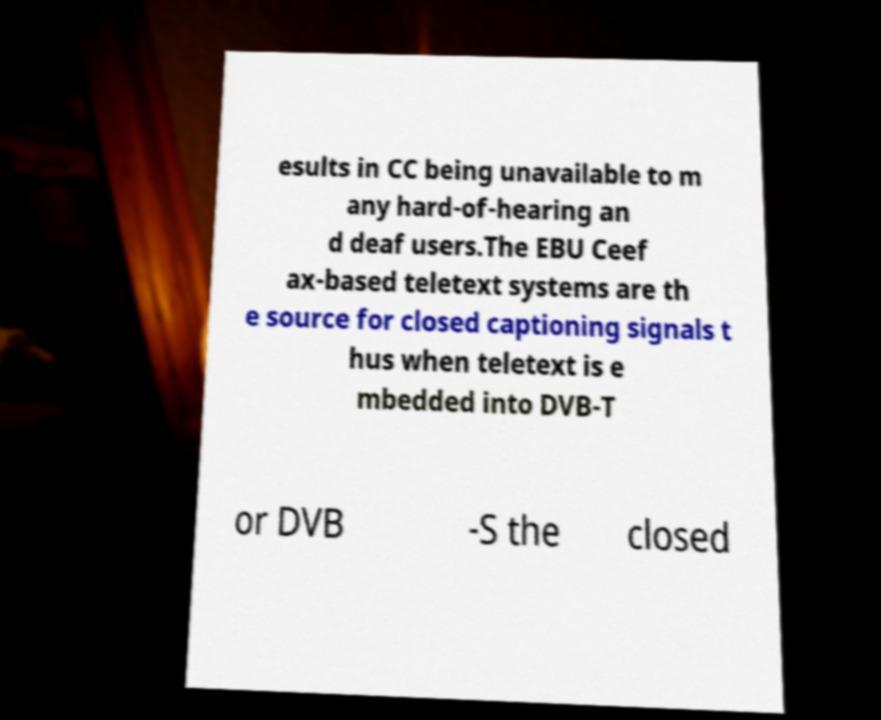Could you extract and type out the text from this image? esults in CC being unavailable to m any hard-of-hearing an d deaf users.The EBU Ceef ax-based teletext systems are th e source for closed captioning signals t hus when teletext is e mbedded into DVB-T or DVB -S the closed 